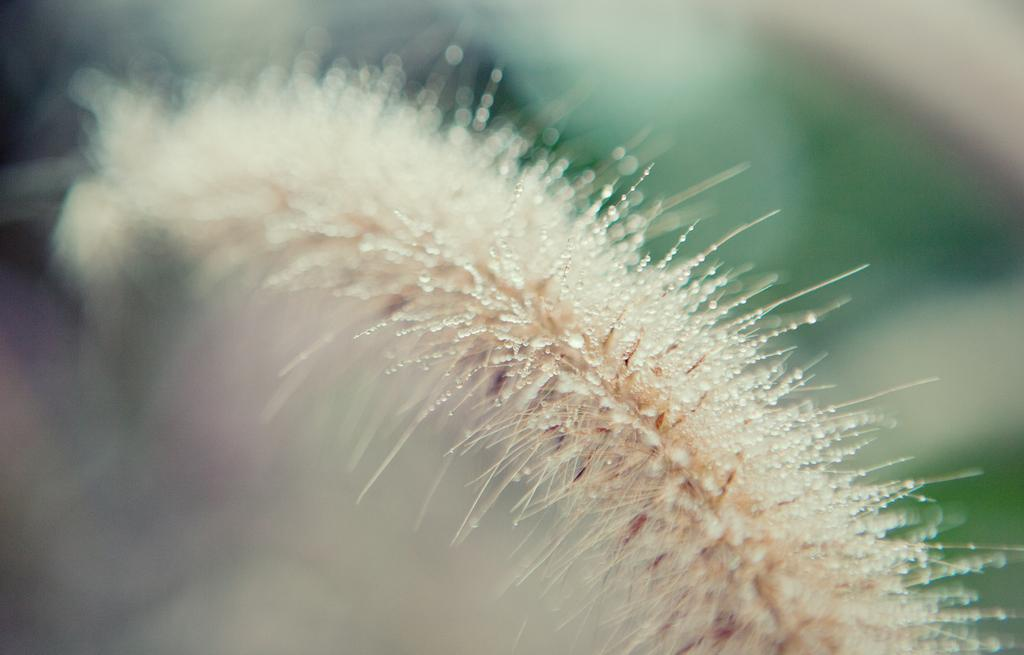What is the main subject of the image? There is a flower in the image. Can you describe the flower's appearance? The flower has water drops on it. What can be observed about the background of the image? The background of the image is blurred. What type of ornament is hanging from the flower in the image? There is no ornament hanging from the flower in the image; it only has water drops on it. What material is the marble table that the flower is placed on in the image? There is no marble table present in the image; the flower is not placed on a table. 